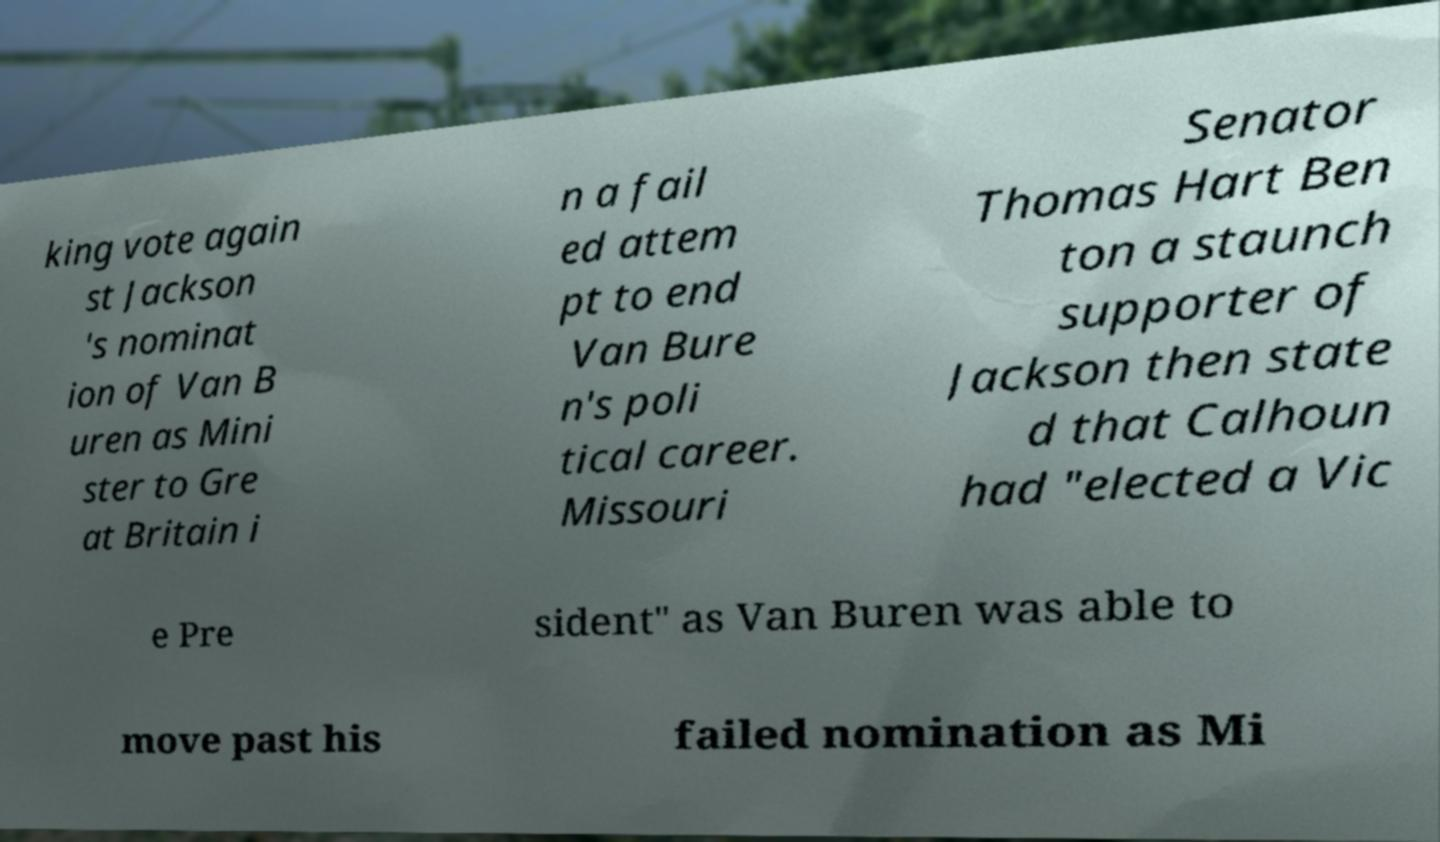I need the written content from this picture converted into text. Can you do that? king vote again st Jackson 's nominat ion of Van B uren as Mini ster to Gre at Britain i n a fail ed attem pt to end Van Bure n's poli tical career. Missouri Senator Thomas Hart Ben ton a staunch supporter of Jackson then state d that Calhoun had "elected a Vic e Pre sident" as Van Buren was able to move past his failed nomination as Mi 